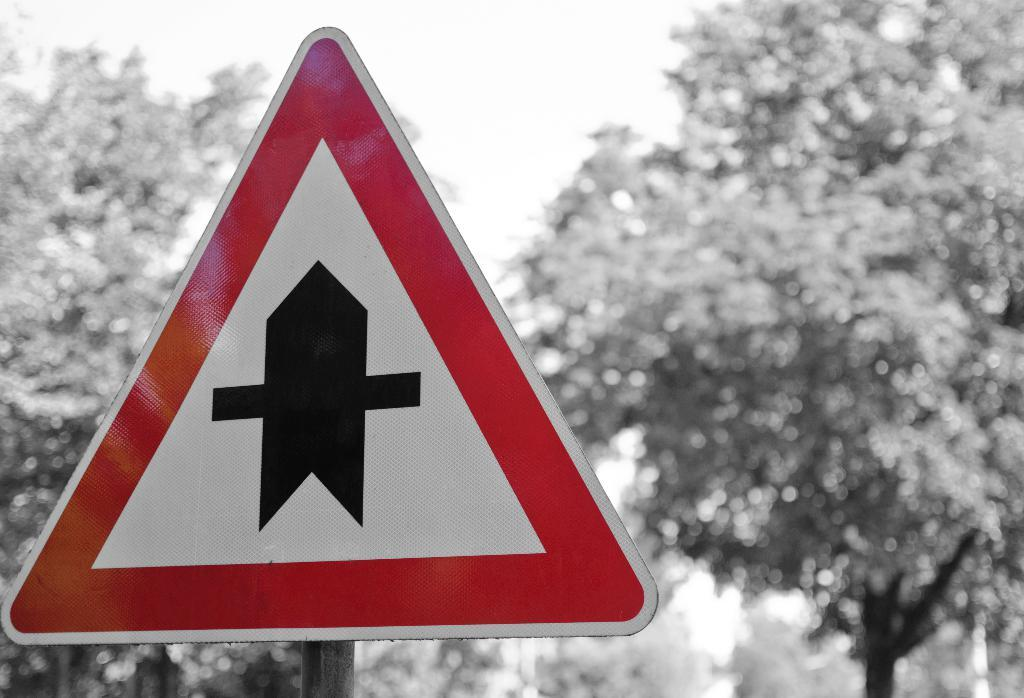What type of natural scenery can be seen in the background of the image? There are trees in the background of the image. What man-made object is present in the image? There is a sign board in the image. What other object can be seen in the image? There is a pole in the image. What time is displayed on the sign board in the image? There is no time displayed on the sign board in the image. Is there a whip visible in the image? No, there is no whip present in the image. 